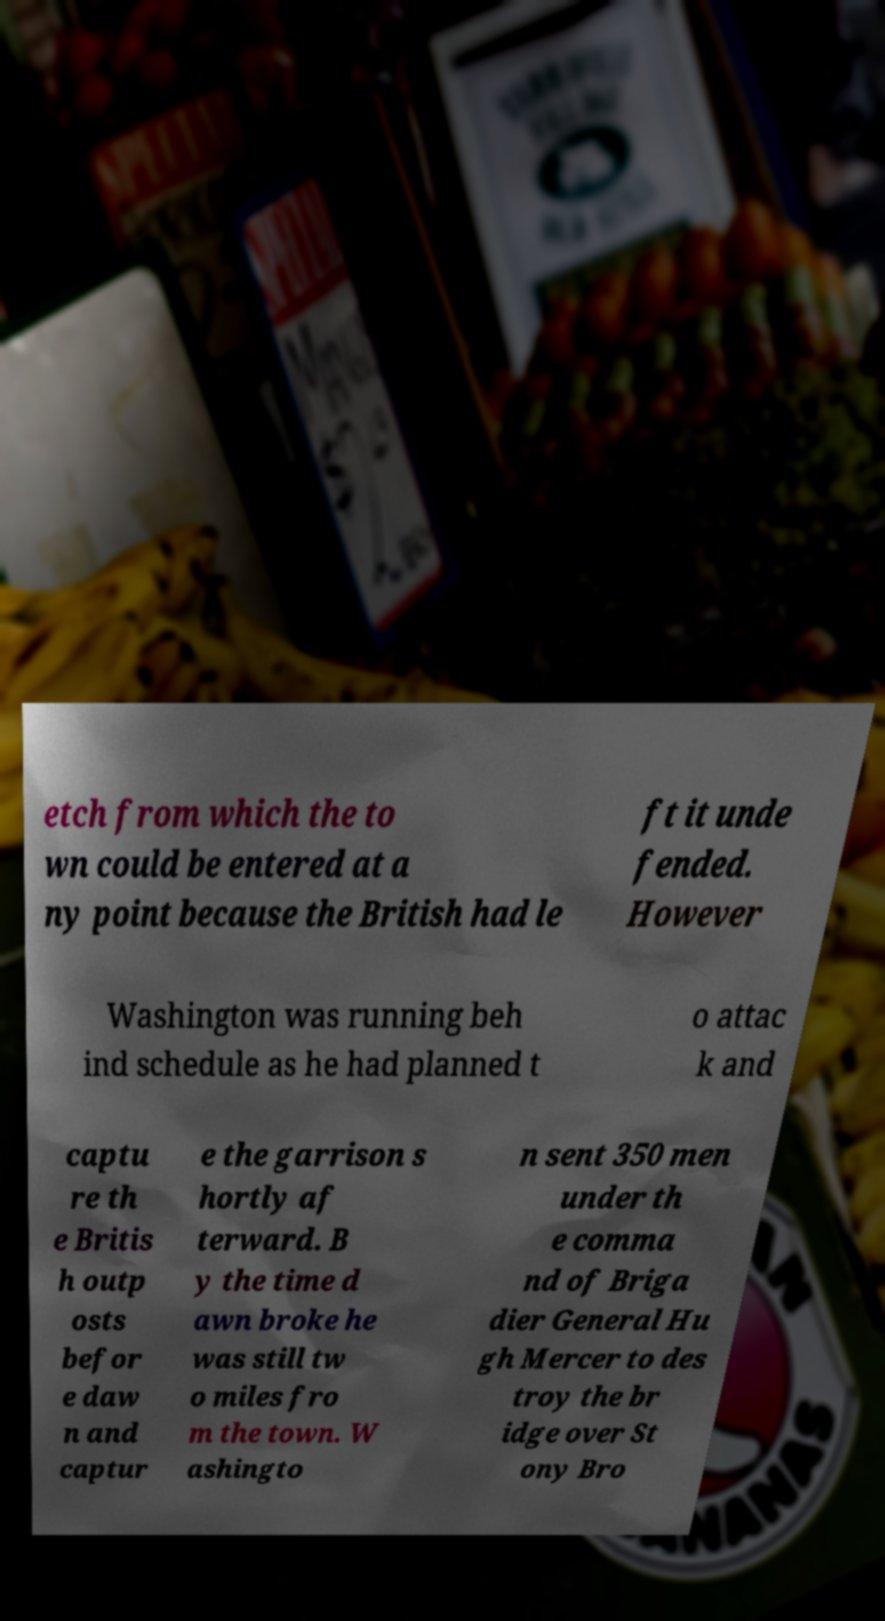Please identify and transcribe the text found in this image. etch from which the to wn could be entered at a ny point because the British had le ft it unde fended. However Washington was running beh ind schedule as he had planned t o attac k and captu re th e Britis h outp osts befor e daw n and captur e the garrison s hortly af terward. B y the time d awn broke he was still tw o miles fro m the town. W ashingto n sent 350 men under th e comma nd of Briga dier General Hu gh Mercer to des troy the br idge over St ony Bro 